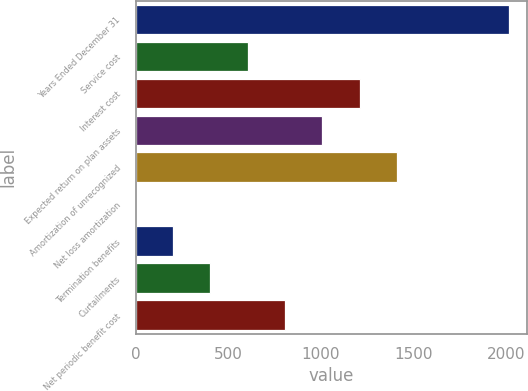<chart> <loc_0><loc_0><loc_500><loc_500><bar_chart><fcel>Years Ended December 31<fcel>Service cost<fcel>Interest cost<fcel>Expected return on plan assets<fcel>Amortization of unrecognized<fcel>Net loss amortization<fcel>Termination benefits<fcel>Curtailments<fcel>Net periodic benefit cost<nl><fcel>2017<fcel>605.8<fcel>1210.6<fcel>1009<fcel>1412.2<fcel>1<fcel>202.6<fcel>404.2<fcel>807.4<nl></chart> 